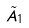<formula> <loc_0><loc_0><loc_500><loc_500>\tilde { A } _ { 1 }</formula> 